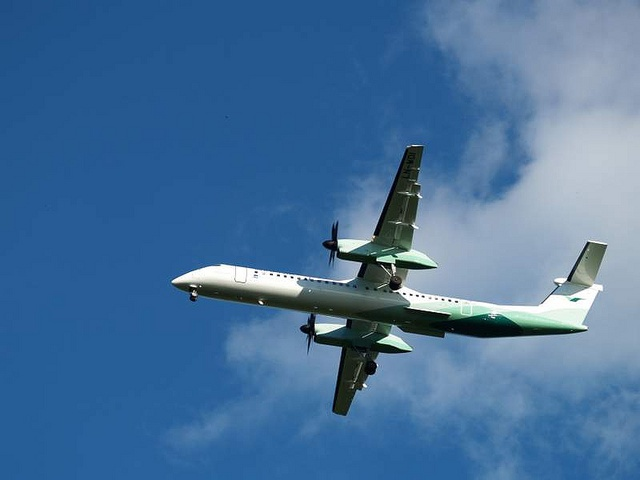Describe the objects in this image and their specific colors. I can see a airplane in blue, black, ivory, gray, and darkgray tones in this image. 